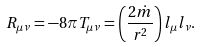Convert formula to latex. <formula><loc_0><loc_0><loc_500><loc_500>R _ { \mu \nu } = - 8 \pi T _ { \mu \nu } = \left ( \frac { 2 \dot { m } } { r ^ { 2 } } \right ) l _ { \mu } l _ { \nu } .</formula> 